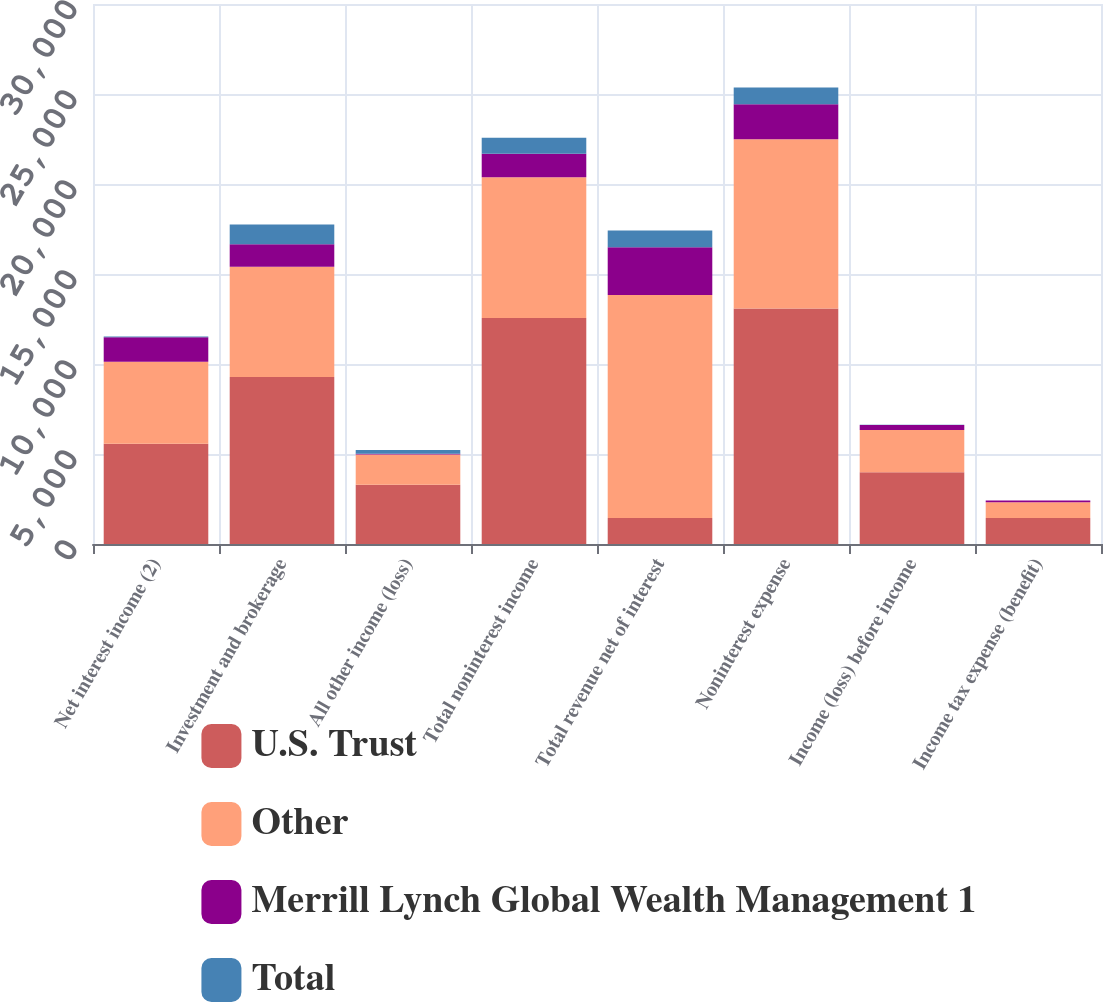Convert chart to OTSL. <chart><loc_0><loc_0><loc_500><loc_500><stacked_bar_chart><ecel><fcel>Net interest income (2)<fcel>Investment and brokerage<fcel>All other income (loss)<fcel>Total noninterest income<fcel>Total revenue net of interest<fcel>Noninterest expense<fcel>Income (loss) before income<fcel>Income tax expense (benefit)<nl><fcel>U.S. Trust<fcel>5564<fcel>9273<fcel>3286<fcel>12559<fcel>1446<fcel>13077<fcel>3985<fcel>1446<nl><fcel>Other<fcel>4567<fcel>6130<fcel>1684<fcel>7814<fcel>12381<fcel>9411<fcel>2351<fcel>870<nl><fcel>Merrill Lynch Global Wealth Management 1<fcel>1361<fcel>1254<fcel>48<fcel>1302<fcel>2663<fcel>1945<fcel>276<fcel>102<nl><fcel>Total<fcel>32<fcel>1090<fcel>201<fcel>889<fcel>921<fcel>932<fcel>11<fcel>4<nl></chart> 